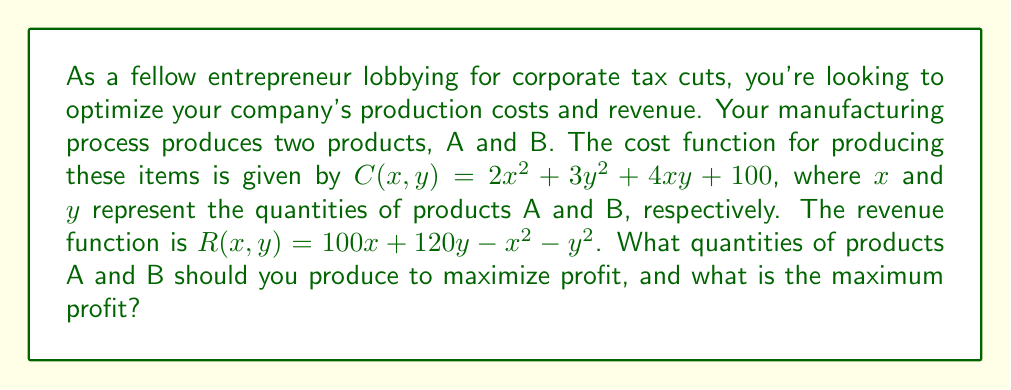Teach me how to tackle this problem. Let's approach this step-by-step:

1) First, we need to define the profit function. Profit is revenue minus cost:
   $P(x, y) = R(x, y) - C(x, y)$

2) Substituting the given functions:
   $P(x, y) = (100x + 120y - x^2 - y^2) - (2x^2 + 3y^2 + 4xy + 100)$

3) Simplifying:
   $P(x, y) = 100x + 120y - x^2 - y^2 - 2x^2 - 3y^2 - 4xy - 100$
   $P(x, y) = 100x + 120y - 3x^2 - 4y^2 - 4xy - 100$

4) To find the maximum profit, we need to find the partial derivatives with respect to x and y and set them to zero:

   $\frac{\partial P}{\partial x} = 100 - 6x - 4y = 0$
   $\frac{\partial P}{\partial y} = 120 - 8y - 4x = 0$

5) Solve this system of equations:
   From the first equation: $x = \frac{100 - 4y}{6}$
   Substituting into the second equation:
   $120 - 8y - 4(\frac{100 - 4y}{6}) = 0$
   $720 - 48y - 400 + 16y = 0$
   $320 - 32y = 0$
   $y = 10$

6) Substituting back:
   $x = \frac{100 - 4(10)}{6} = 10$

7) Therefore, to maximize profit, produce 10 units each of products A and B.

8) To find the maximum profit, substitute these values into the profit function:
   $P(10, 10) = 100(10) + 120(10) - 3(10)^2 - 4(10)^2 - 4(10)(10) - 100$
               $= 1000 + 1200 - 300 - 400 - 400 - 100$
               $= 1000$
Answer: Produce 10 units each of A and B; Maximum profit is $1000. 